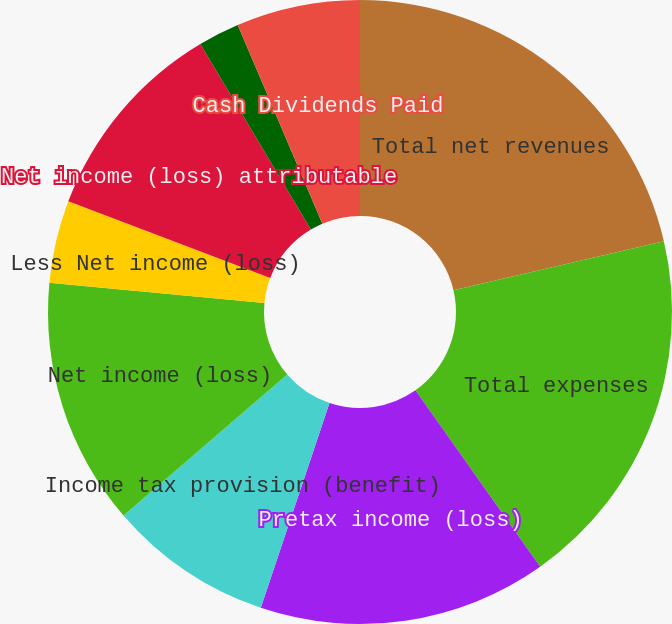<chart> <loc_0><loc_0><loc_500><loc_500><pie_chart><fcel>Total net revenues<fcel>Total expenses<fcel>Pretax income (loss)<fcel>Income tax provision (benefit)<fcel>Net income (loss)<fcel>Less Net income (loss)<fcel>Net income (loss) attributable<fcel>Basic<fcel>Cash Dividends Paid Per Common<fcel>Cash Dividends Paid<nl><fcel>21.36%<fcel>18.84%<fcel>14.95%<fcel>8.54%<fcel>12.81%<fcel>4.27%<fcel>10.68%<fcel>2.14%<fcel>0.0%<fcel>6.41%<nl></chart> 